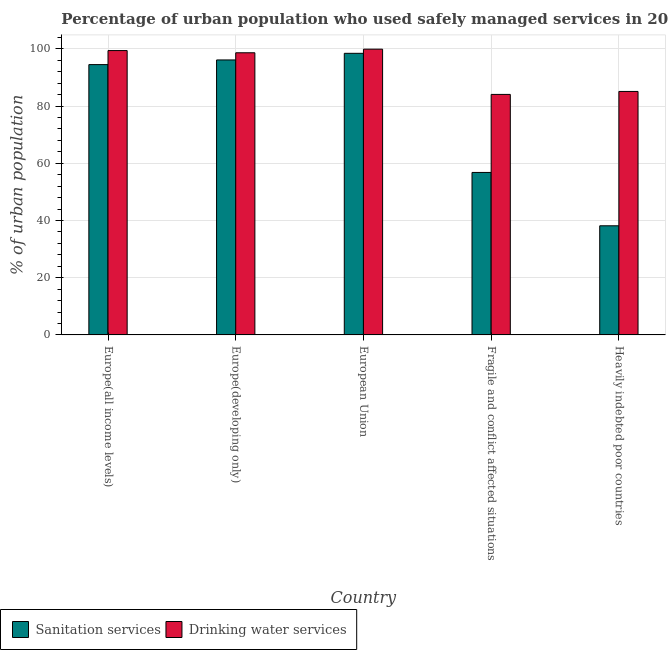How many different coloured bars are there?
Give a very brief answer. 2. How many groups of bars are there?
Provide a succinct answer. 5. Are the number of bars on each tick of the X-axis equal?
Give a very brief answer. Yes. How many bars are there on the 3rd tick from the right?
Provide a short and direct response. 2. What is the label of the 4th group of bars from the left?
Your response must be concise. Fragile and conflict affected situations. What is the percentage of urban population who used drinking water services in Fragile and conflict affected situations?
Make the answer very short. 84.09. Across all countries, what is the maximum percentage of urban population who used drinking water services?
Give a very brief answer. 99.91. Across all countries, what is the minimum percentage of urban population who used drinking water services?
Ensure brevity in your answer.  84.09. In which country was the percentage of urban population who used drinking water services minimum?
Offer a terse response. Fragile and conflict affected situations. What is the total percentage of urban population who used sanitation services in the graph?
Give a very brief answer. 384.08. What is the difference between the percentage of urban population who used sanitation services in Europe(developing only) and that in Fragile and conflict affected situations?
Ensure brevity in your answer.  39.34. What is the difference between the percentage of urban population who used sanitation services in Heavily indebted poor countries and the percentage of urban population who used drinking water services in Europe(developing only)?
Your response must be concise. -60.5. What is the average percentage of urban population who used sanitation services per country?
Keep it short and to the point. 76.82. What is the difference between the percentage of urban population who used drinking water services and percentage of urban population who used sanitation services in Europe(all income levels)?
Keep it short and to the point. 4.91. In how many countries, is the percentage of urban population who used sanitation services greater than 36 %?
Keep it short and to the point. 5. What is the ratio of the percentage of urban population who used drinking water services in European Union to that in Fragile and conflict affected situations?
Offer a terse response. 1.19. Is the difference between the percentage of urban population who used drinking water services in European Union and Fragile and conflict affected situations greater than the difference between the percentage of urban population who used sanitation services in European Union and Fragile and conflict affected situations?
Offer a terse response. No. What is the difference between the highest and the second highest percentage of urban population who used drinking water services?
Ensure brevity in your answer.  0.49. What is the difference between the highest and the lowest percentage of urban population who used sanitation services?
Provide a short and direct response. 60.3. In how many countries, is the percentage of urban population who used sanitation services greater than the average percentage of urban population who used sanitation services taken over all countries?
Make the answer very short. 3. What does the 1st bar from the left in Heavily indebted poor countries represents?
Your answer should be very brief. Sanitation services. What does the 1st bar from the right in Fragile and conflict affected situations represents?
Offer a very short reply. Drinking water services. How many bars are there?
Give a very brief answer. 10. What is the difference between two consecutive major ticks on the Y-axis?
Offer a terse response. 20. Does the graph contain any zero values?
Your answer should be compact. No. Does the graph contain grids?
Provide a short and direct response. Yes. Where does the legend appear in the graph?
Ensure brevity in your answer.  Bottom left. What is the title of the graph?
Offer a very short reply. Percentage of urban population who used safely managed services in 2011. Does "Manufacturing industries and construction" appear as one of the legend labels in the graph?
Keep it short and to the point. No. What is the label or title of the Y-axis?
Your answer should be very brief. % of urban population. What is the % of urban population of Sanitation services in Europe(all income levels)?
Your answer should be very brief. 94.52. What is the % of urban population of Drinking water services in Europe(all income levels)?
Ensure brevity in your answer.  99.42. What is the % of urban population in Sanitation services in Europe(developing only)?
Provide a short and direct response. 96.15. What is the % of urban population in Drinking water services in Europe(developing only)?
Keep it short and to the point. 98.65. What is the % of urban population of Sanitation services in European Union?
Offer a terse response. 98.46. What is the % of urban population in Drinking water services in European Union?
Keep it short and to the point. 99.91. What is the % of urban population in Sanitation services in Fragile and conflict affected situations?
Keep it short and to the point. 56.81. What is the % of urban population of Drinking water services in Fragile and conflict affected situations?
Provide a short and direct response. 84.09. What is the % of urban population in Sanitation services in Heavily indebted poor countries?
Make the answer very short. 38.15. What is the % of urban population in Drinking water services in Heavily indebted poor countries?
Offer a terse response. 85.13. Across all countries, what is the maximum % of urban population of Sanitation services?
Your answer should be compact. 98.46. Across all countries, what is the maximum % of urban population in Drinking water services?
Offer a terse response. 99.91. Across all countries, what is the minimum % of urban population of Sanitation services?
Ensure brevity in your answer.  38.15. Across all countries, what is the minimum % of urban population of Drinking water services?
Provide a short and direct response. 84.09. What is the total % of urban population in Sanitation services in the graph?
Your response must be concise. 384.08. What is the total % of urban population of Drinking water services in the graph?
Offer a very short reply. 467.21. What is the difference between the % of urban population in Sanitation services in Europe(all income levels) and that in Europe(developing only)?
Keep it short and to the point. -1.63. What is the difference between the % of urban population in Drinking water services in Europe(all income levels) and that in Europe(developing only)?
Offer a very short reply. 0.77. What is the difference between the % of urban population in Sanitation services in Europe(all income levels) and that in European Union?
Provide a succinct answer. -3.94. What is the difference between the % of urban population in Drinking water services in Europe(all income levels) and that in European Union?
Keep it short and to the point. -0.49. What is the difference between the % of urban population in Sanitation services in Europe(all income levels) and that in Fragile and conflict affected situations?
Your answer should be compact. 37.71. What is the difference between the % of urban population in Drinking water services in Europe(all income levels) and that in Fragile and conflict affected situations?
Ensure brevity in your answer.  15.33. What is the difference between the % of urban population in Sanitation services in Europe(all income levels) and that in Heavily indebted poor countries?
Provide a succinct answer. 56.36. What is the difference between the % of urban population of Drinking water services in Europe(all income levels) and that in Heavily indebted poor countries?
Offer a very short reply. 14.29. What is the difference between the % of urban population in Sanitation services in Europe(developing only) and that in European Union?
Make the answer very short. -2.31. What is the difference between the % of urban population of Drinking water services in Europe(developing only) and that in European Union?
Offer a terse response. -1.26. What is the difference between the % of urban population in Sanitation services in Europe(developing only) and that in Fragile and conflict affected situations?
Make the answer very short. 39.34. What is the difference between the % of urban population in Drinking water services in Europe(developing only) and that in Fragile and conflict affected situations?
Your answer should be very brief. 14.56. What is the difference between the % of urban population in Sanitation services in Europe(developing only) and that in Heavily indebted poor countries?
Provide a short and direct response. 57.99. What is the difference between the % of urban population of Drinking water services in Europe(developing only) and that in Heavily indebted poor countries?
Keep it short and to the point. 13.52. What is the difference between the % of urban population of Sanitation services in European Union and that in Fragile and conflict affected situations?
Ensure brevity in your answer.  41.65. What is the difference between the % of urban population of Drinking water services in European Union and that in Fragile and conflict affected situations?
Offer a terse response. 15.82. What is the difference between the % of urban population in Sanitation services in European Union and that in Heavily indebted poor countries?
Your response must be concise. 60.3. What is the difference between the % of urban population in Drinking water services in European Union and that in Heavily indebted poor countries?
Keep it short and to the point. 14.78. What is the difference between the % of urban population of Sanitation services in Fragile and conflict affected situations and that in Heavily indebted poor countries?
Your answer should be very brief. 18.65. What is the difference between the % of urban population in Drinking water services in Fragile and conflict affected situations and that in Heavily indebted poor countries?
Your response must be concise. -1.04. What is the difference between the % of urban population in Sanitation services in Europe(all income levels) and the % of urban population in Drinking water services in Europe(developing only)?
Provide a short and direct response. -4.14. What is the difference between the % of urban population in Sanitation services in Europe(all income levels) and the % of urban population in Drinking water services in European Union?
Your answer should be very brief. -5.4. What is the difference between the % of urban population of Sanitation services in Europe(all income levels) and the % of urban population of Drinking water services in Fragile and conflict affected situations?
Make the answer very short. 10.42. What is the difference between the % of urban population in Sanitation services in Europe(all income levels) and the % of urban population in Drinking water services in Heavily indebted poor countries?
Ensure brevity in your answer.  9.38. What is the difference between the % of urban population of Sanitation services in Europe(developing only) and the % of urban population of Drinking water services in European Union?
Give a very brief answer. -3.77. What is the difference between the % of urban population in Sanitation services in Europe(developing only) and the % of urban population in Drinking water services in Fragile and conflict affected situations?
Offer a very short reply. 12.06. What is the difference between the % of urban population of Sanitation services in Europe(developing only) and the % of urban population of Drinking water services in Heavily indebted poor countries?
Your response must be concise. 11.01. What is the difference between the % of urban population in Sanitation services in European Union and the % of urban population in Drinking water services in Fragile and conflict affected situations?
Your response must be concise. 14.37. What is the difference between the % of urban population in Sanitation services in European Union and the % of urban population in Drinking water services in Heavily indebted poor countries?
Offer a very short reply. 13.33. What is the difference between the % of urban population of Sanitation services in Fragile and conflict affected situations and the % of urban population of Drinking water services in Heavily indebted poor countries?
Provide a succinct answer. -28.33. What is the average % of urban population in Sanitation services per country?
Ensure brevity in your answer.  76.82. What is the average % of urban population in Drinking water services per country?
Offer a terse response. 93.44. What is the difference between the % of urban population of Sanitation services and % of urban population of Drinking water services in Europe(all income levels)?
Make the answer very short. -4.91. What is the difference between the % of urban population in Sanitation services and % of urban population in Drinking water services in Europe(developing only)?
Provide a succinct answer. -2.51. What is the difference between the % of urban population of Sanitation services and % of urban population of Drinking water services in European Union?
Your answer should be very brief. -1.45. What is the difference between the % of urban population in Sanitation services and % of urban population in Drinking water services in Fragile and conflict affected situations?
Offer a terse response. -27.29. What is the difference between the % of urban population of Sanitation services and % of urban population of Drinking water services in Heavily indebted poor countries?
Make the answer very short. -46.98. What is the ratio of the % of urban population of Drinking water services in Europe(all income levels) to that in Europe(developing only)?
Give a very brief answer. 1.01. What is the ratio of the % of urban population of Sanitation services in Europe(all income levels) to that in European Union?
Keep it short and to the point. 0.96. What is the ratio of the % of urban population in Drinking water services in Europe(all income levels) to that in European Union?
Ensure brevity in your answer.  1. What is the ratio of the % of urban population of Sanitation services in Europe(all income levels) to that in Fragile and conflict affected situations?
Your answer should be compact. 1.66. What is the ratio of the % of urban population of Drinking water services in Europe(all income levels) to that in Fragile and conflict affected situations?
Provide a short and direct response. 1.18. What is the ratio of the % of urban population in Sanitation services in Europe(all income levels) to that in Heavily indebted poor countries?
Make the answer very short. 2.48. What is the ratio of the % of urban population of Drinking water services in Europe(all income levels) to that in Heavily indebted poor countries?
Ensure brevity in your answer.  1.17. What is the ratio of the % of urban population of Sanitation services in Europe(developing only) to that in European Union?
Your answer should be compact. 0.98. What is the ratio of the % of urban population in Drinking water services in Europe(developing only) to that in European Union?
Keep it short and to the point. 0.99. What is the ratio of the % of urban population of Sanitation services in Europe(developing only) to that in Fragile and conflict affected situations?
Make the answer very short. 1.69. What is the ratio of the % of urban population of Drinking water services in Europe(developing only) to that in Fragile and conflict affected situations?
Offer a terse response. 1.17. What is the ratio of the % of urban population in Sanitation services in Europe(developing only) to that in Heavily indebted poor countries?
Provide a succinct answer. 2.52. What is the ratio of the % of urban population in Drinking water services in Europe(developing only) to that in Heavily indebted poor countries?
Offer a terse response. 1.16. What is the ratio of the % of urban population of Sanitation services in European Union to that in Fragile and conflict affected situations?
Offer a terse response. 1.73. What is the ratio of the % of urban population of Drinking water services in European Union to that in Fragile and conflict affected situations?
Your response must be concise. 1.19. What is the ratio of the % of urban population in Sanitation services in European Union to that in Heavily indebted poor countries?
Offer a very short reply. 2.58. What is the ratio of the % of urban population in Drinking water services in European Union to that in Heavily indebted poor countries?
Your answer should be compact. 1.17. What is the ratio of the % of urban population of Sanitation services in Fragile and conflict affected situations to that in Heavily indebted poor countries?
Your answer should be compact. 1.49. What is the difference between the highest and the second highest % of urban population of Sanitation services?
Provide a succinct answer. 2.31. What is the difference between the highest and the second highest % of urban population in Drinking water services?
Keep it short and to the point. 0.49. What is the difference between the highest and the lowest % of urban population of Sanitation services?
Provide a short and direct response. 60.3. What is the difference between the highest and the lowest % of urban population in Drinking water services?
Offer a very short reply. 15.82. 